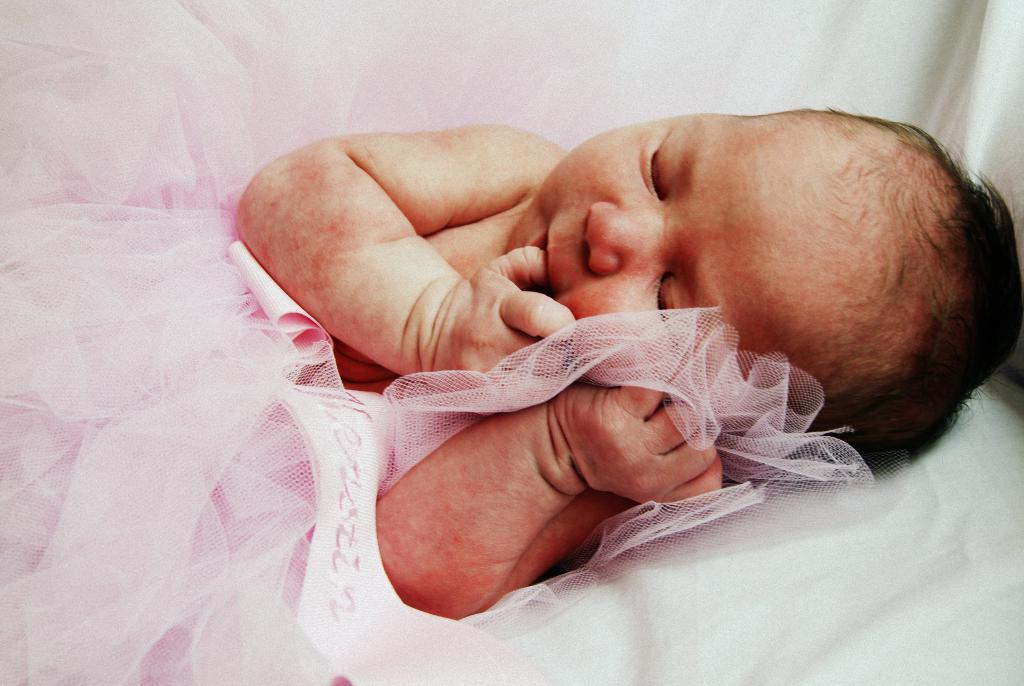What is the main subject of the picture? The main subject of the picture is a baby. What is the baby wearing in the image? The baby is wearing a pink dress. What color is the cloth visible in the background of the image? The cloth in the background of the image is white. What type of airplane is the baby flying in the image? There is no airplane present in the image; it features a baby wearing a pink dress with a white cloth in the background. What degree does the baby have in the image? The baby is not a person who can have a degree, as it is an infant. 